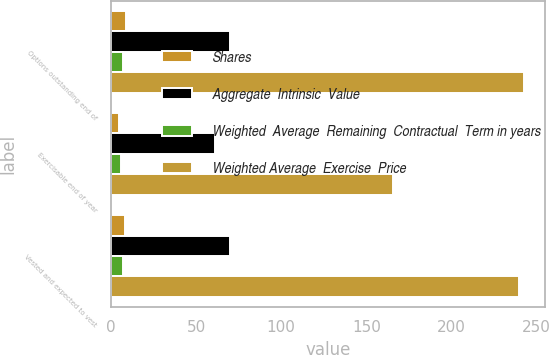Convert chart. <chart><loc_0><loc_0><loc_500><loc_500><stacked_bar_chart><ecel><fcel>Options outstanding end of<fcel>Exercisable end of year<fcel>Vested and expected to vest<nl><fcel>Shares<fcel>8.5<fcel>4.4<fcel>8.3<nl><fcel>Aggregate  Intrinsic  Value<fcel>70.11<fcel>60.81<fcel>69.73<nl><fcel>Weighted  Average  Remaining  Contractual  Term in years<fcel>7.1<fcel>5.9<fcel>7.1<nl><fcel>Weighted Average  Exercise  Price<fcel>243<fcel>166<fcel>240<nl></chart> 